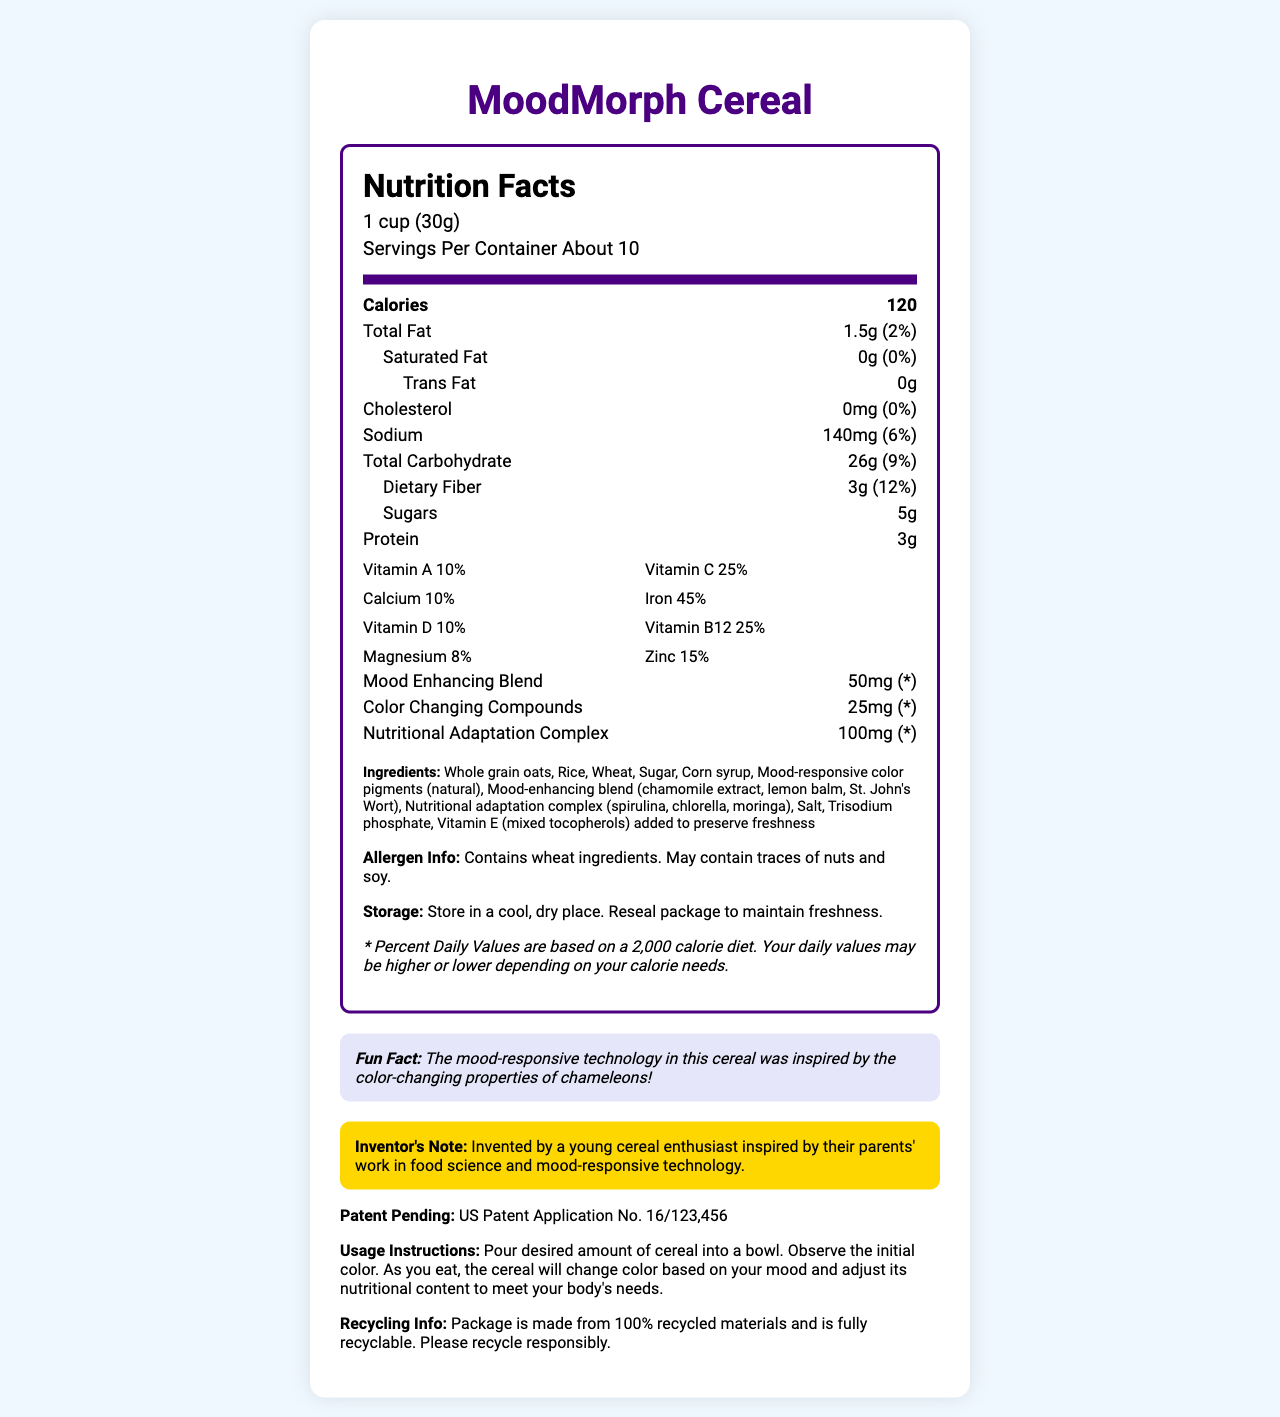what is the serving size? The serving size is listed at the top of the nutrition label.
Answer: 1 cup (30g) how many calories are in one serving? The number of calories per serving is clearly stated in the calories section.
Answer: 120 what is the primary ingredient in MoodMorph Cereal? The ingredients are listed in descending order by weight, with whole grain oats being the first ingredient.
Answer: Whole grain oats how many grams of dietary fiber are in each serving? The amount of dietary fiber is listed under the total carbohydrate section.
Answer: 3g what percentage of the daily value of iron does one serving provide? The daily value percentage for iron is located in the vitamineral grid.
Answer: 45% how much sodium is in one serving? The amount of sodium per serving is listed in the sodium section of the nutrition label.
Answer: 140mg is the product made from recycled materials? The recycling info mentions that the package is made from 100% recycled materials.
Answer: Yes summarize the entire document briefly. This summary captures the essential details about MoodMorph Cereal's nutritional content, ingredients, inspirational background, and additional product information.
Answer: MoodMorph Cereal is a color-changing cereal that adapts to the consumer's mood and nutritional needs. Each serving is 1 cup (30g) and contains 120 calories. It is enriched with various vitamins and minerals, and includes mood-enhancing ingredients and a nutritional adaptation complex. The cereal was inspired by chameleons, invented by a young cereal enthusiast, and is patent-pending. It contains wheat, may have traces of nuts and soy, and uses a recyclable package. Instructions for use and storage are also provided. what activities might the cereal be good for, considering its nutritional content and mood-enhancing properties? The document does not provide specific information on what activities the cereal's nutritional content and mood-enhancing properties would be particularly suitable for.
Answer: Cannot be determined what is the fun fact mentioned about MoodMorph Cereal? The fun fact is located in a distinct section and states this information.
Answer: The mood-responsive technology in this cereal was inspired by the color-changing properties of chameleons. what is the purpose of the vitamin E (mixed tocopherols) in the cereal? The ingredients list specifies that vitamin E (mixed tocopherols) is added to preserve freshness.
Answer: To preserve freshness 